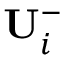Convert formula to latex. <formula><loc_0><loc_0><loc_500><loc_500>U _ { i } ^ { - }</formula> 